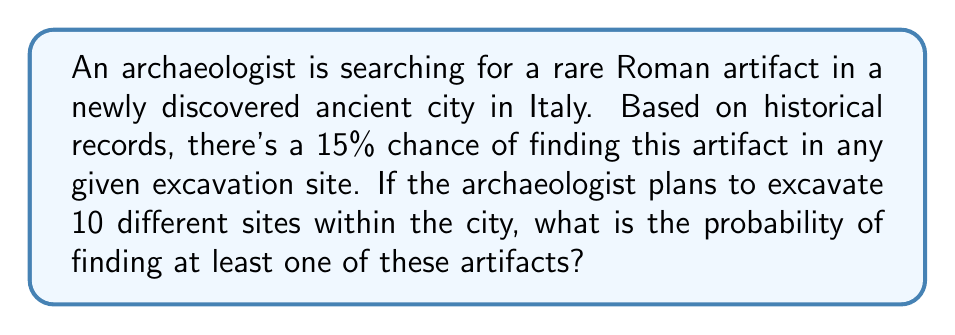Provide a solution to this math problem. Let's approach this step-by-step:

1) First, let's define our events:
   Let A be the event of finding at least one artifact.
   Let B be the event of not finding any artifacts.

2) We know that P(finding an artifact in one site) = 0.15

3) The probability of not finding an artifact in one site is:
   P(not finding in one site) = 1 - 0.15 = 0.85

4) For 10 independent excavations, the probability of not finding any artifacts is:
   P(B) = $0.85^{10}$

5) The probability of finding at least one artifact is the complement of not finding any:
   P(A) = 1 - P(B) = 1 - $0.85^{10}$

6) Let's calculate this:
   P(A) = 1 - $0.85^{10}$ = 1 - 0.1968 = 0.8032

7) Converting to a percentage:
   0.8032 * 100 = 80.32%

Therefore, the probability of finding at least one of these artifacts in 10 excavations is approximately 80.32%.
Answer: 80.32% 